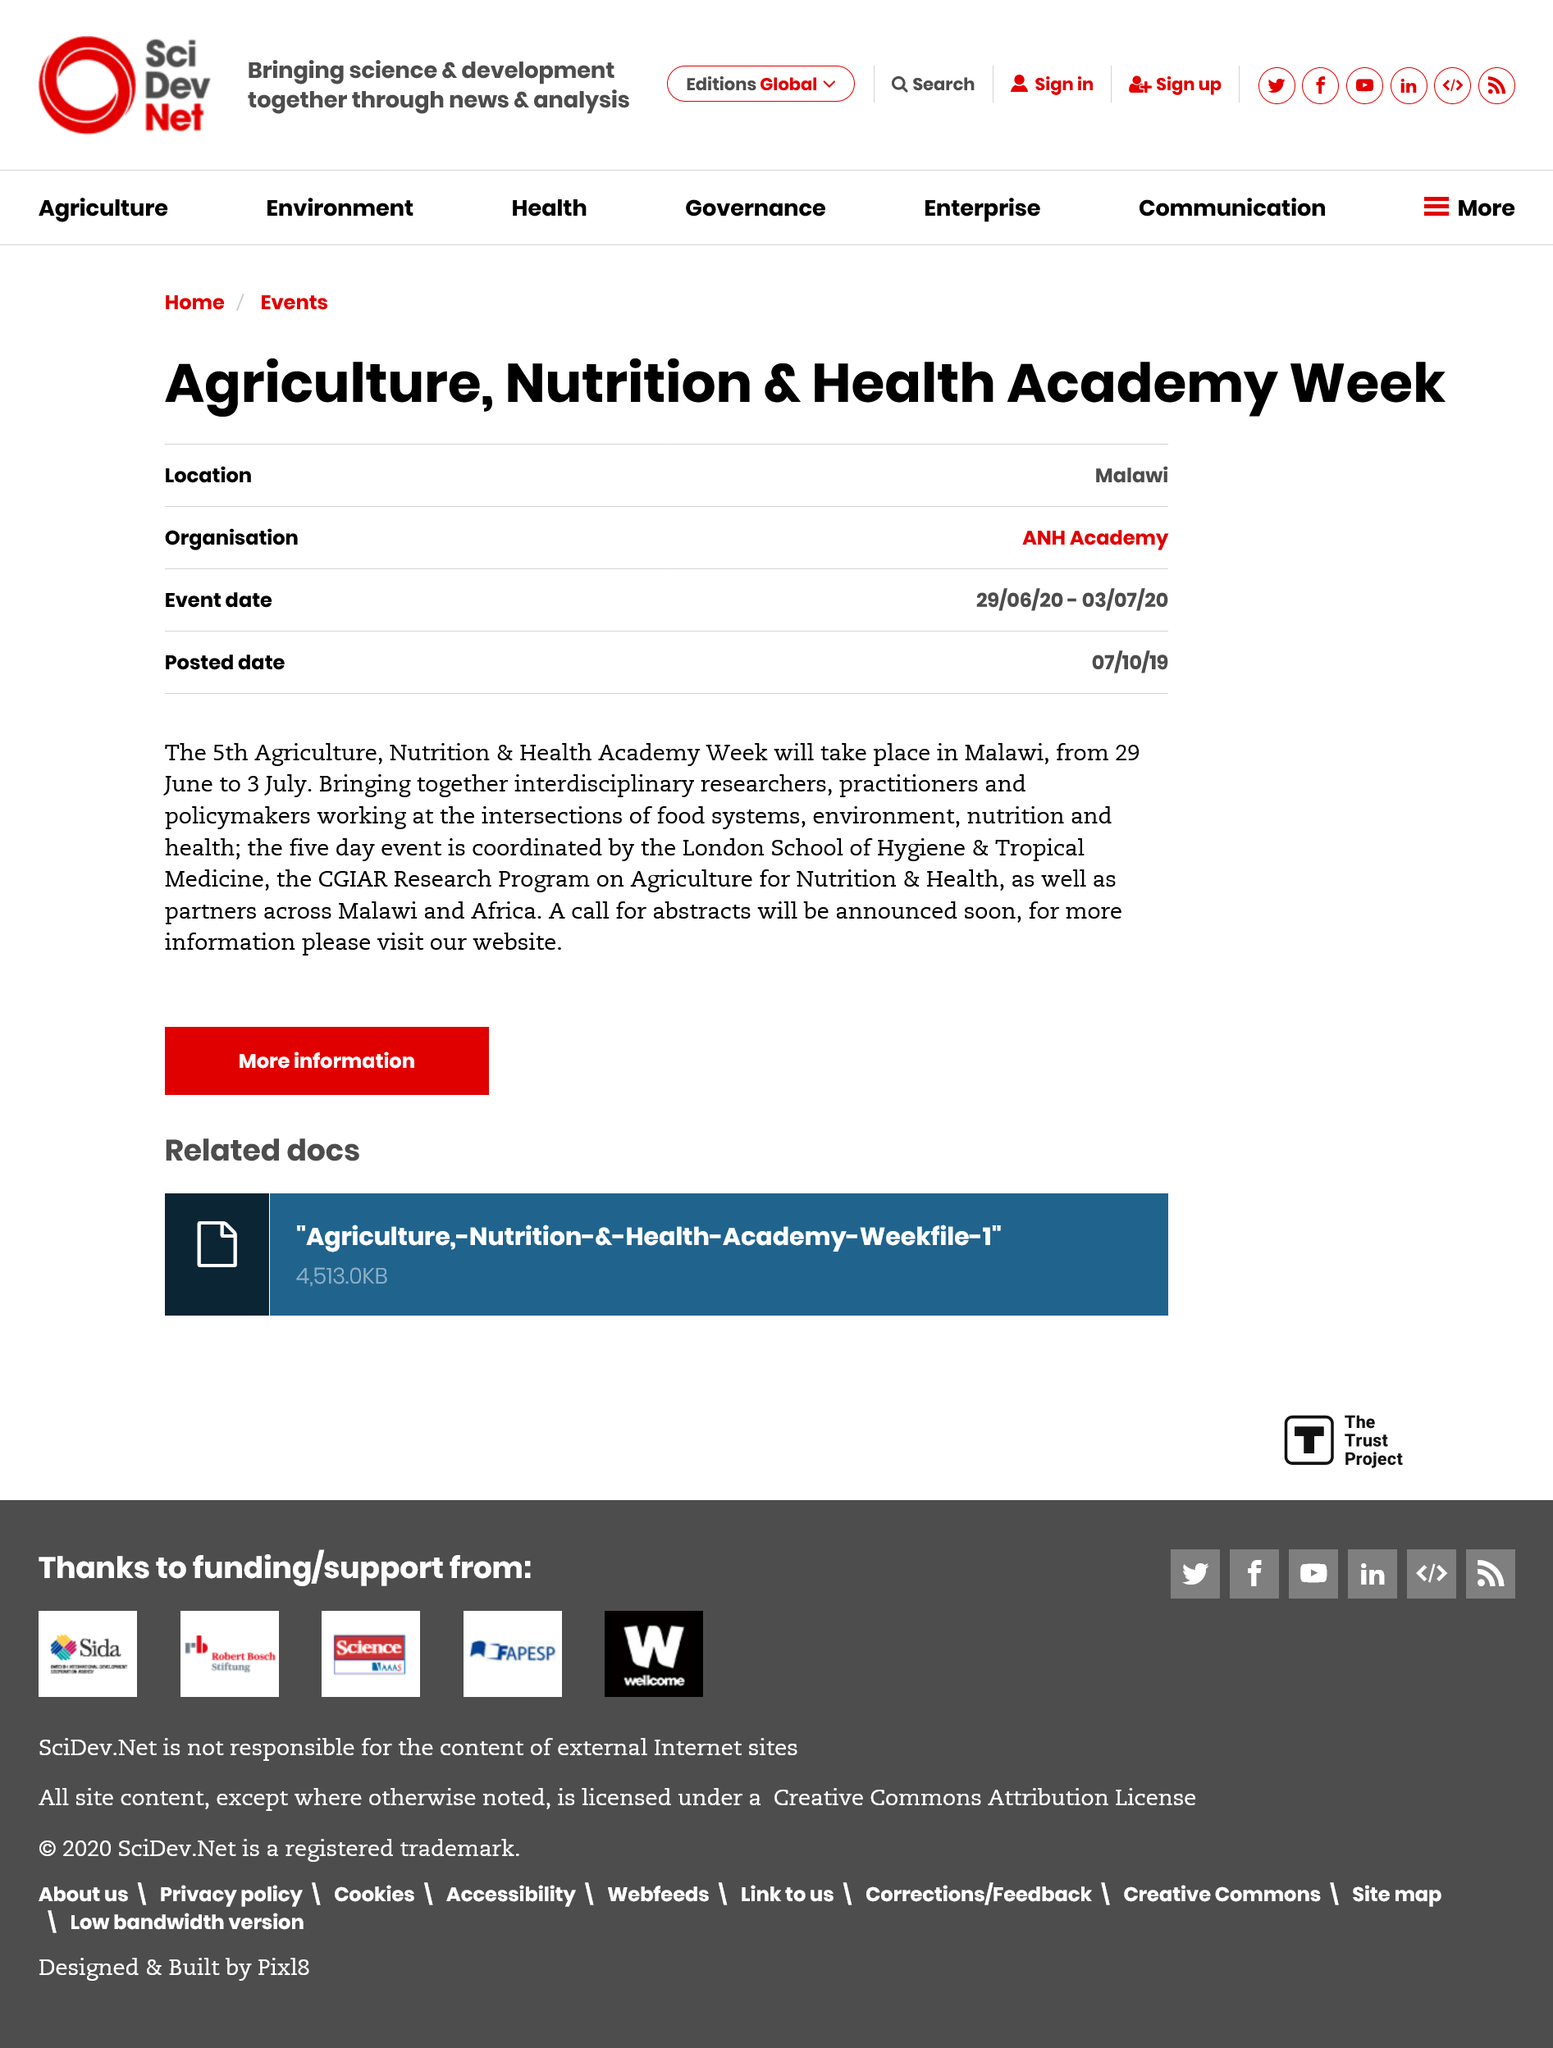Identify some key points in this picture. The week-long event will commence on June 29, 2020. The location of the Agriculture, Nutrition and Health Academy week is in Malawi. The London School of Hygiene and Tropical Medicine plays a vital role as a coordinator of the event. 